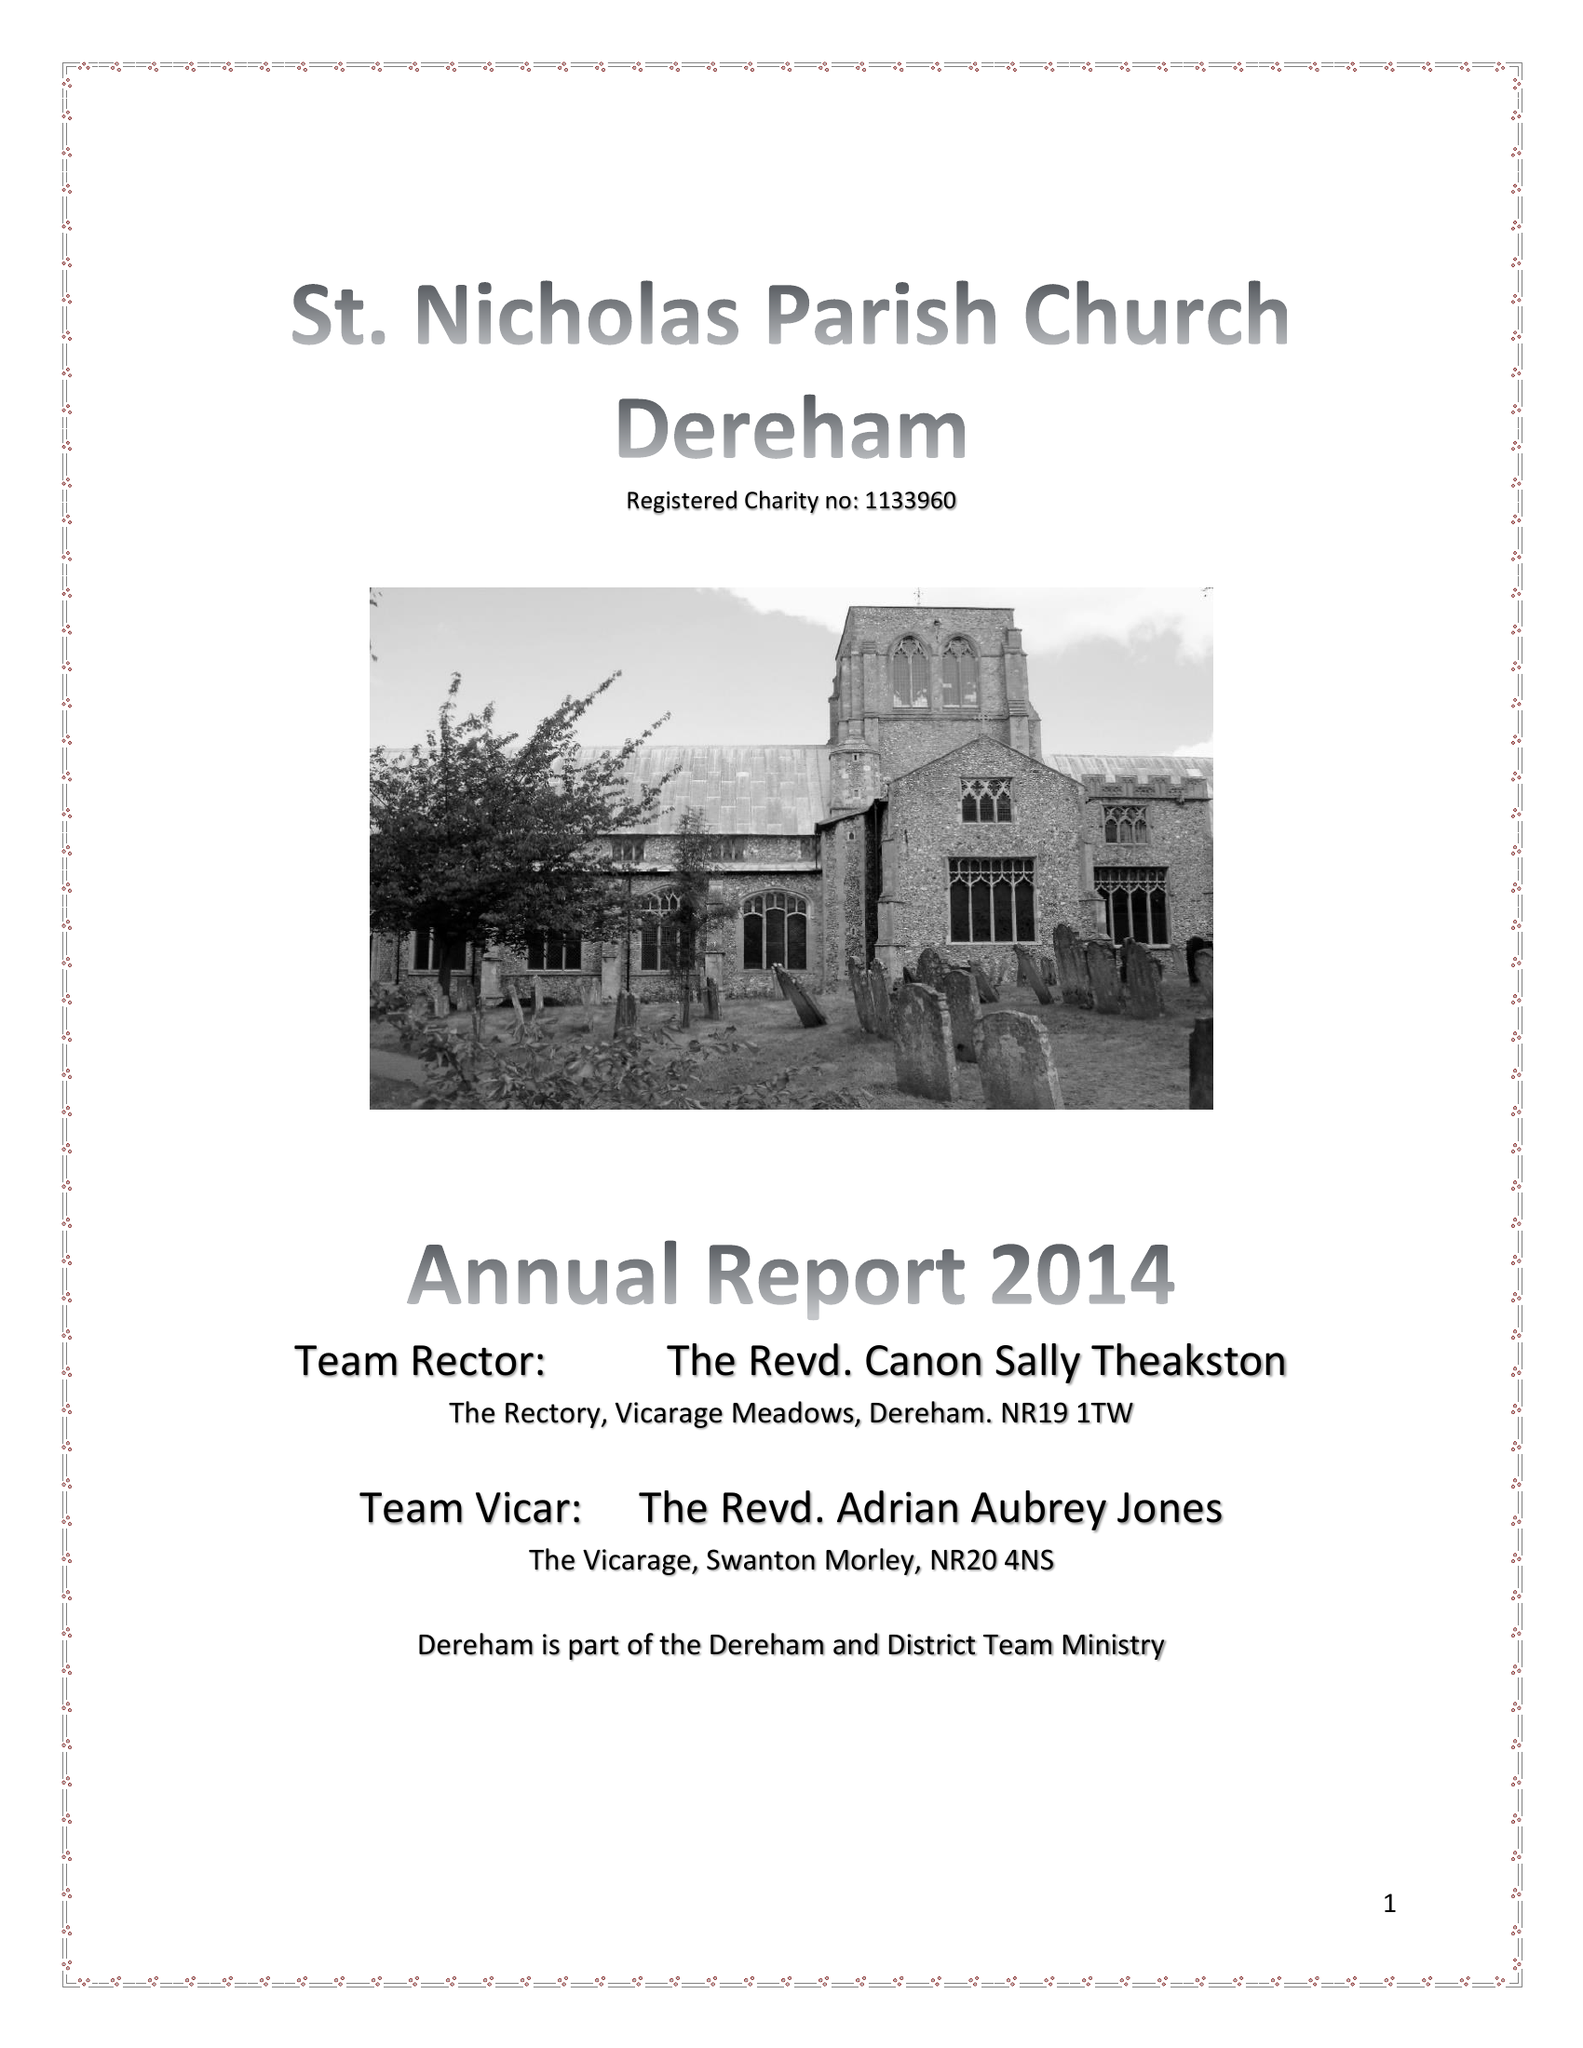What is the value for the address__street_line?
Answer the question using a single word or phrase. CHURCH STREET 